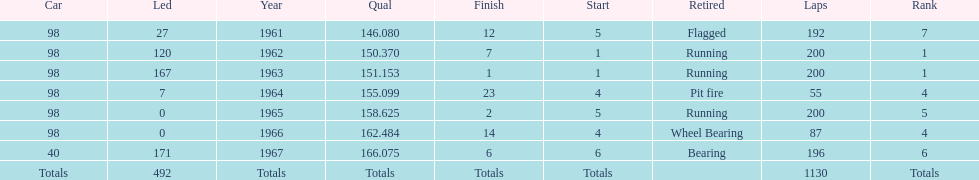What car achieved the highest qual? 40. 